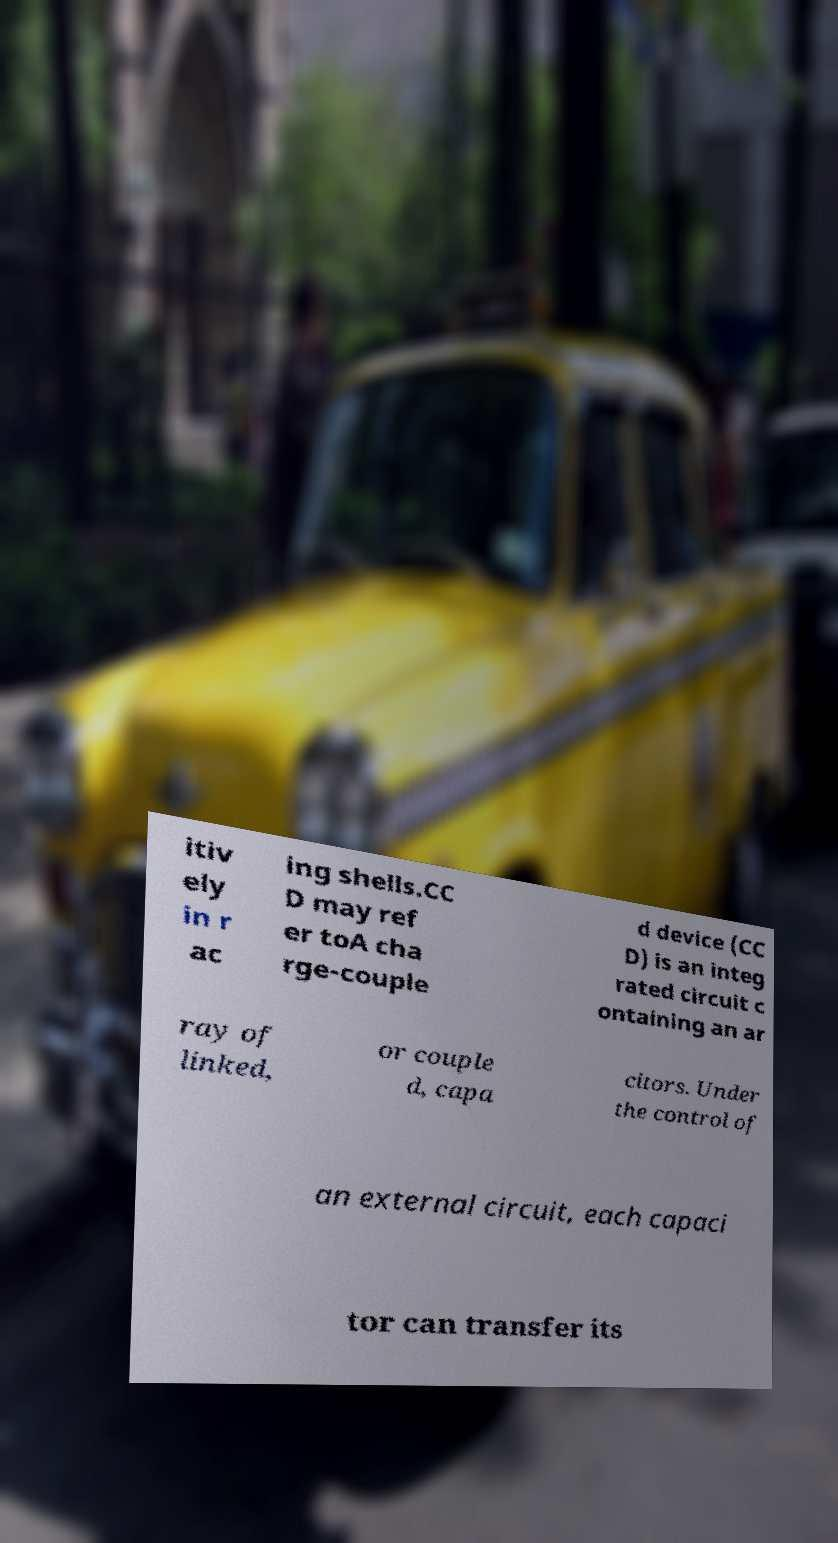Could you assist in decoding the text presented in this image and type it out clearly? itiv ely in r ac ing shells.CC D may ref er toA cha rge-couple d device (CC D) is an integ rated circuit c ontaining an ar ray of linked, or couple d, capa citors. Under the control of an external circuit, each capaci tor can transfer its 